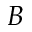<formula> <loc_0><loc_0><loc_500><loc_500>B</formula> 